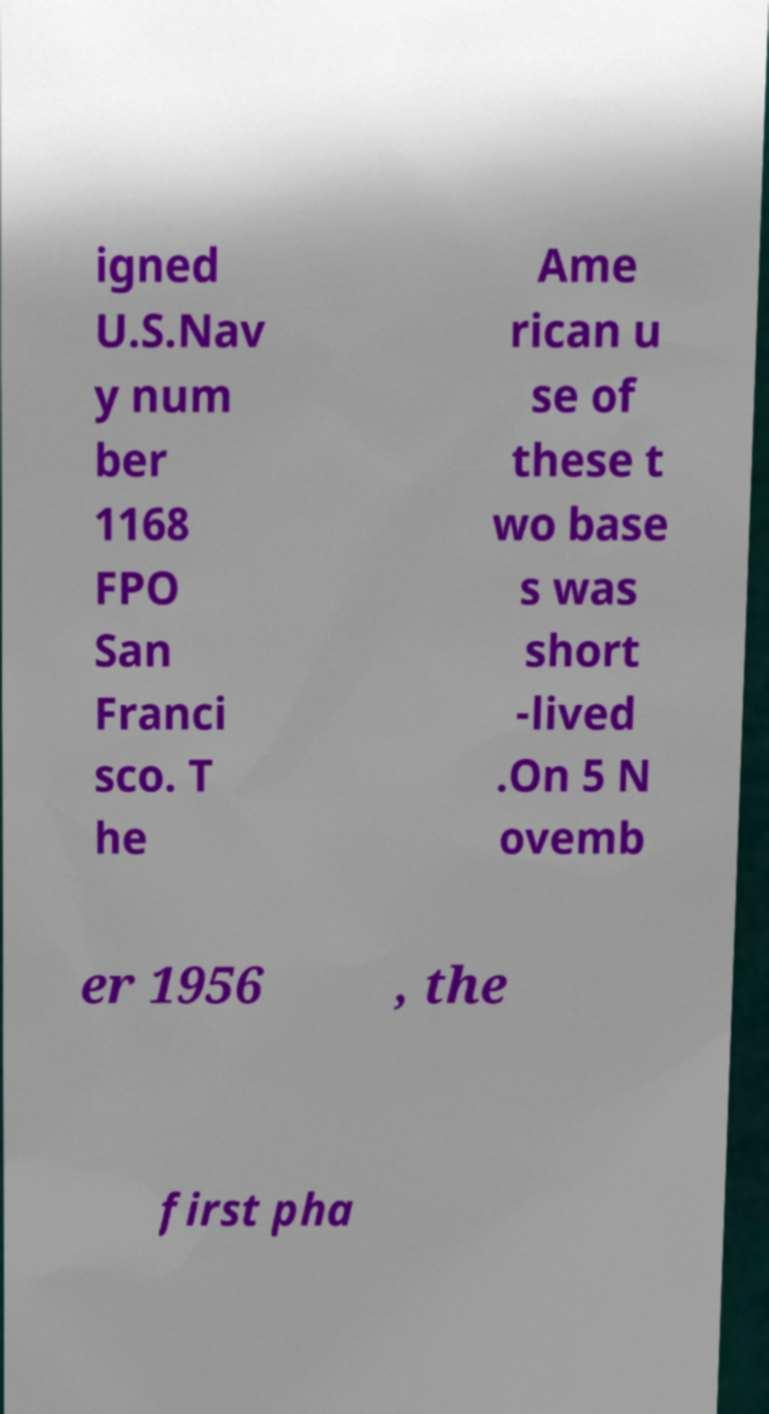There's text embedded in this image that I need extracted. Can you transcribe it verbatim? igned U.S.Nav y num ber 1168 FPO San Franci sco. T he Ame rican u se of these t wo base s was short -lived .On 5 N ovemb er 1956 , the first pha 